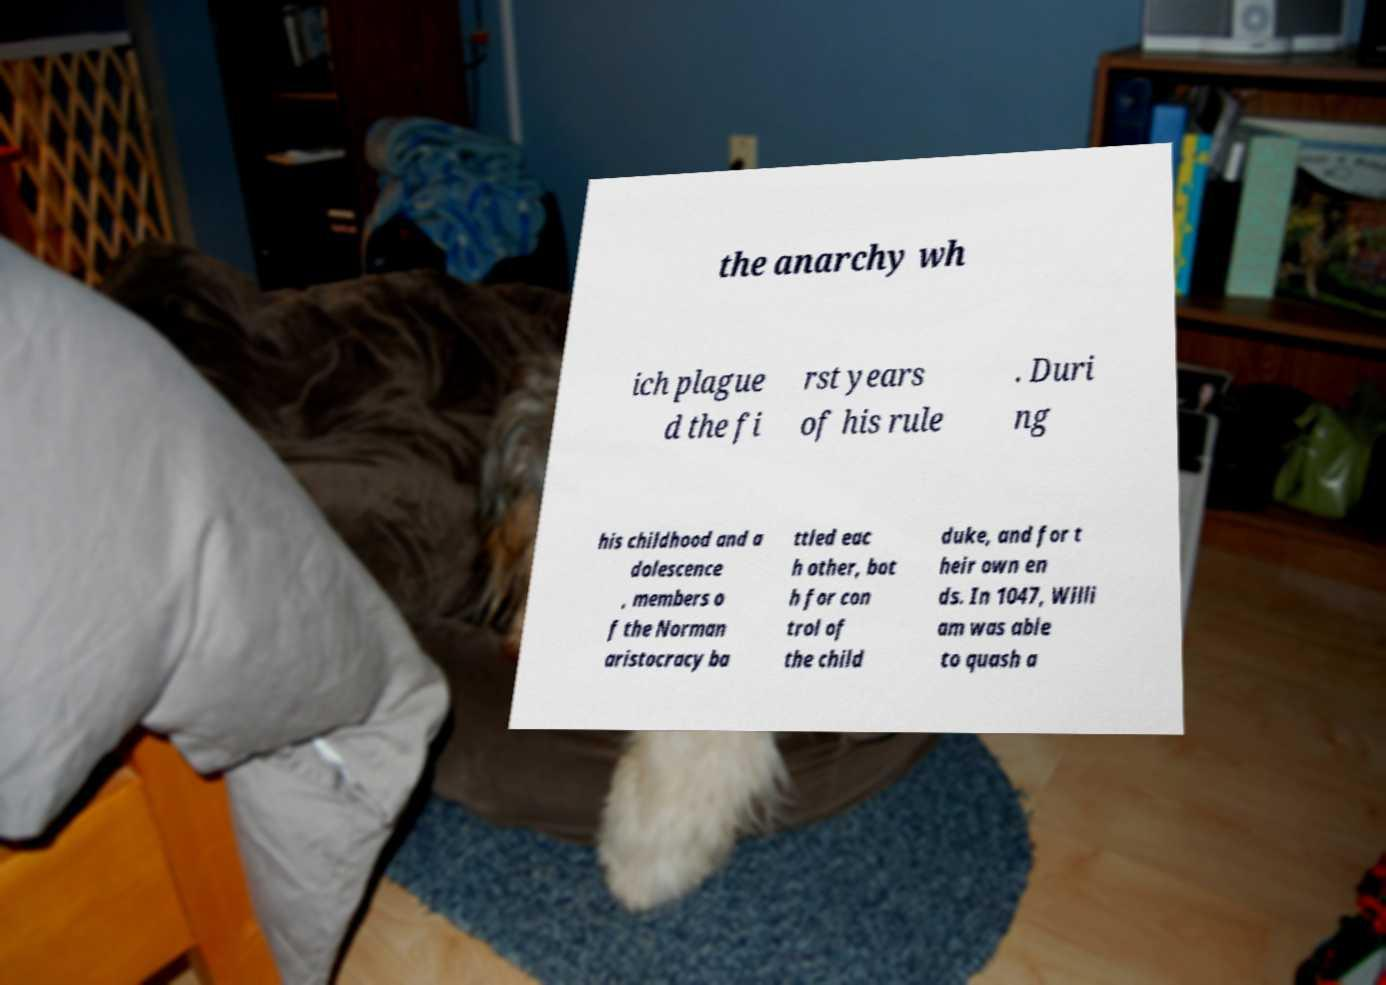Can you read and provide the text displayed in the image?This photo seems to have some interesting text. Can you extract and type it out for me? the anarchy wh ich plague d the fi rst years of his rule . Duri ng his childhood and a dolescence , members o f the Norman aristocracy ba ttled eac h other, bot h for con trol of the child duke, and for t heir own en ds. In 1047, Willi am was able to quash a 